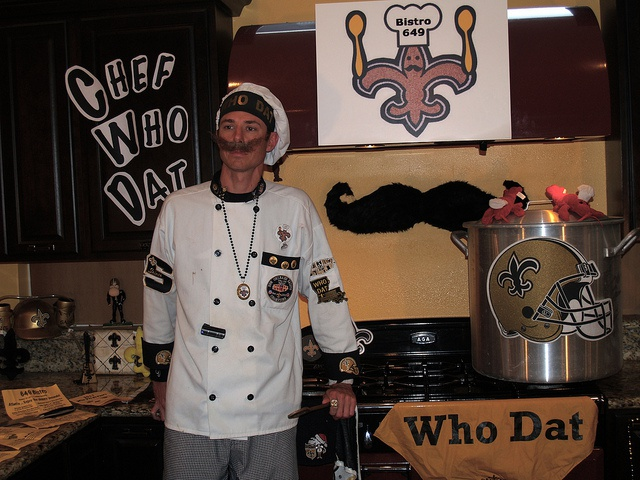Describe the objects in this image and their specific colors. I can see people in black, darkgray, gray, and maroon tones, oven in black, gray, maroon, and darkgray tones, oven in black, gray, and maroon tones, and spoon in black, maroon, and gray tones in this image. 